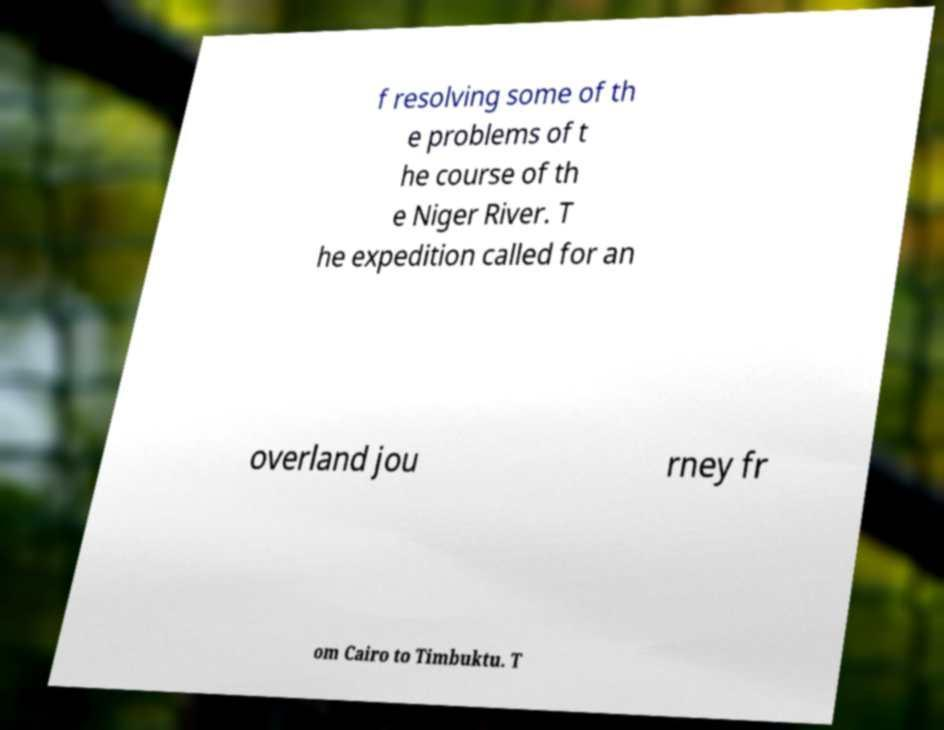Please identify and transcribe the text found in this image. f resolving some of th e problems of t he course of th e Niger River. T he expedition called for an overland jou rney fr om Cairo to Timbuktu. T 